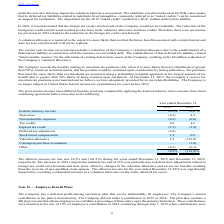From Par Technology's financial document, What was the effective income tax rate during the years ended December 31, 2019 and December 31, 2018 respectively? The document shows two values: 18.9% and (141.8)%. From the document: "18.9% (141.8)% 18.9% (141.8)%..." Also, What led to the decrease in 2019 compared to statutory tax rate of 21%? deferred tax adjustments related to foreign tax credit carryforwards and state taxes, offset by changes in the valuation allowance and excess tax benefits resulting from the exercise of non-qualified stock options.. The document states: "to statutory tax rate of 21% was primarily due to deferred tax adjustments related to foreign tax credit carryforwards and state taxes, offset by chan..." Also, What impacted the effective tax rate for the year ended December 31, 2018? by recording a substantial increase in a valuation allowance on the entire deferred tax assets.. The document states: "ended December 31,2018 was significantly impacted by recording a substantial increase in a valuation allowance on the entire deferred tax assets...." Also, can you calculate: What is the change in Non deductible expenses between December 31, 2018 and 2019? Based on the calculation: 0.3-0.6, the result is -0.3 (percentage). This is based on the information: "Non deductible expenses (0.3) (0.6) Non deductible expenses (0.3) (0.6)..." The key data points involved are: 0.6. Also, can you calculate: What is the change in Tax credits from December 31, 2018 and 2019? Based on the calculation: 4.0-4.6, the result is -0.6 (percentage). This is based on the information: "Tax credits 4.0 4.6 Tax credits 4.0 4.6..." The key data points involved are: 4.0, 4.6. Also, can you calculate: What is the average Non deductible expenses for December 31, 2018 and 2019? To answer this question, I need to perform calculations using the financial data. The calculation is: (0.3+0.6) / 2, which equals 0.45 (percentage). This is based on the information: "Non deductible expenses (0.3) (0.6) Non deductible expenses (0.3) (0.6)..." The key data points involved are: 0.3, 0.6. 